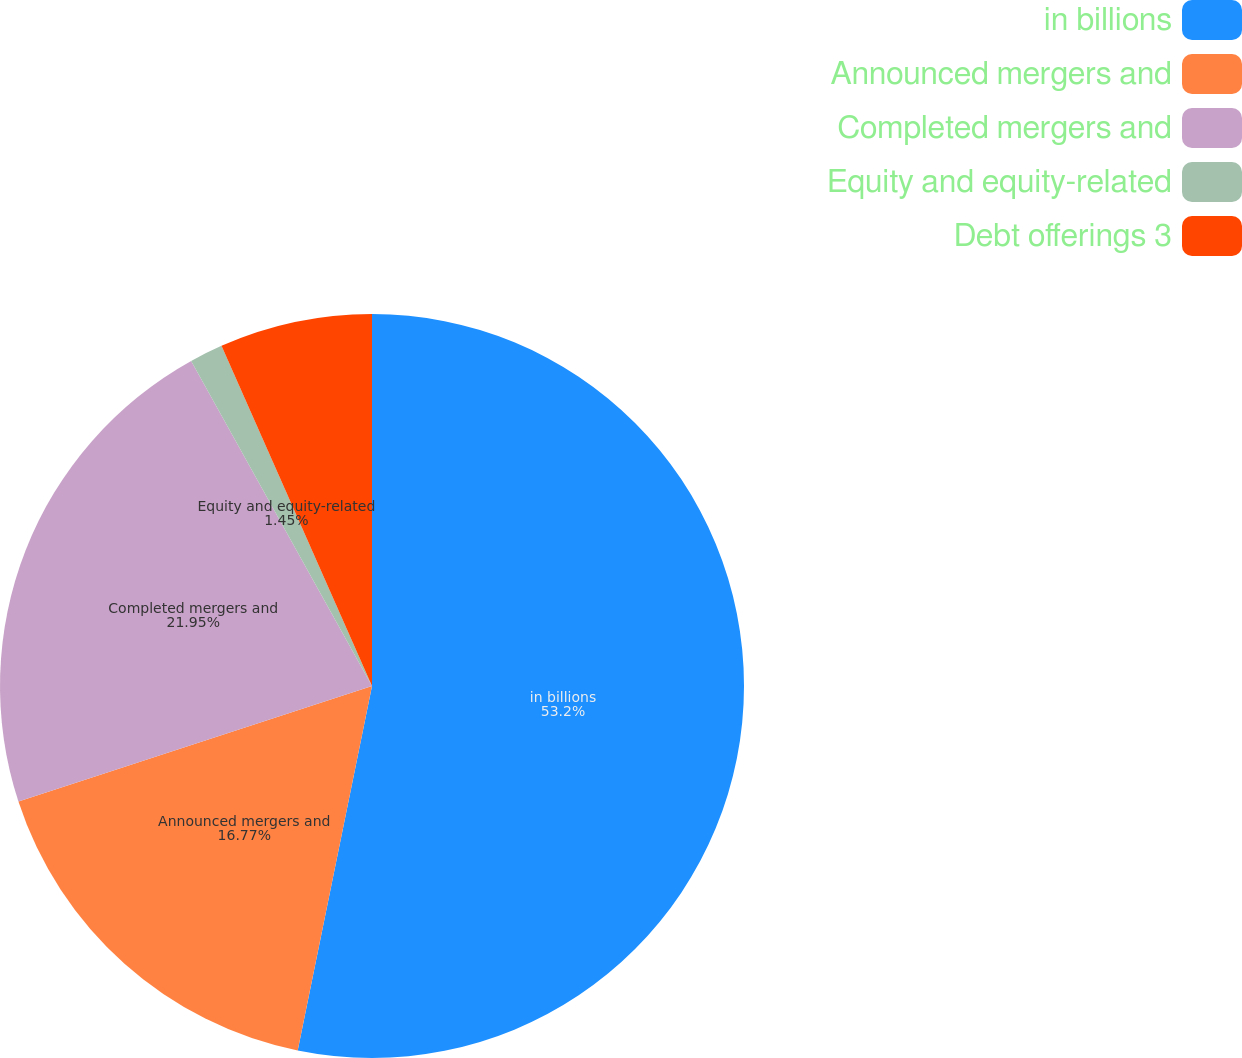<chart> <loc_0><loc_0><loc_500><loc_500><pie_chart><fcel>in billions<fcel>Announced mergers and<fcel>Completed mergers and<fcel>Equity and equity-related<fcel>Debt offerings 3<nl><fcel>53.2%<fcel>16.77%<fcel>21.95%<fcel>1.45%<fcel>6.63%<nl></chart> 